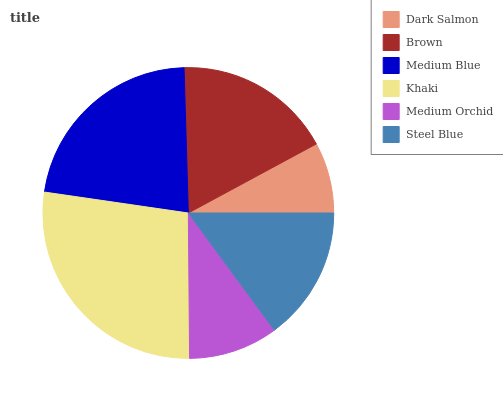Is Dark Salmon the minimum?
Answer yes or no. Yes. Is Khaki the maximum?
Answer yes or no. Yes. Is Brown the minimum?
Answer yes or no. No. Is Brown the maximum?
Answer yes or no. No. Is Brown greater than Dark Salmon?
Answer yes or no. Yes. Is Dark Salmon less than Brown?
Answer yes or no. Yes. Is Dark Salmon greater than Brown?
Answer yes or no. No. Is Brown less than Dark Salmon?
Answer yes or no. No. Is Brown the high median?
Answer yes or no. Yes. Is Steel Blue the low median?
Answer yes or no. Yes. Is Medium Blue the high median?
Answer yes or no. No. Is Medium Orchid the low median?
Answer yes or no. No. 